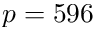Convert formula to latex. <formula><loc_0><loc_0><loc_500><loc_500>p = 5 9 6</formula> 